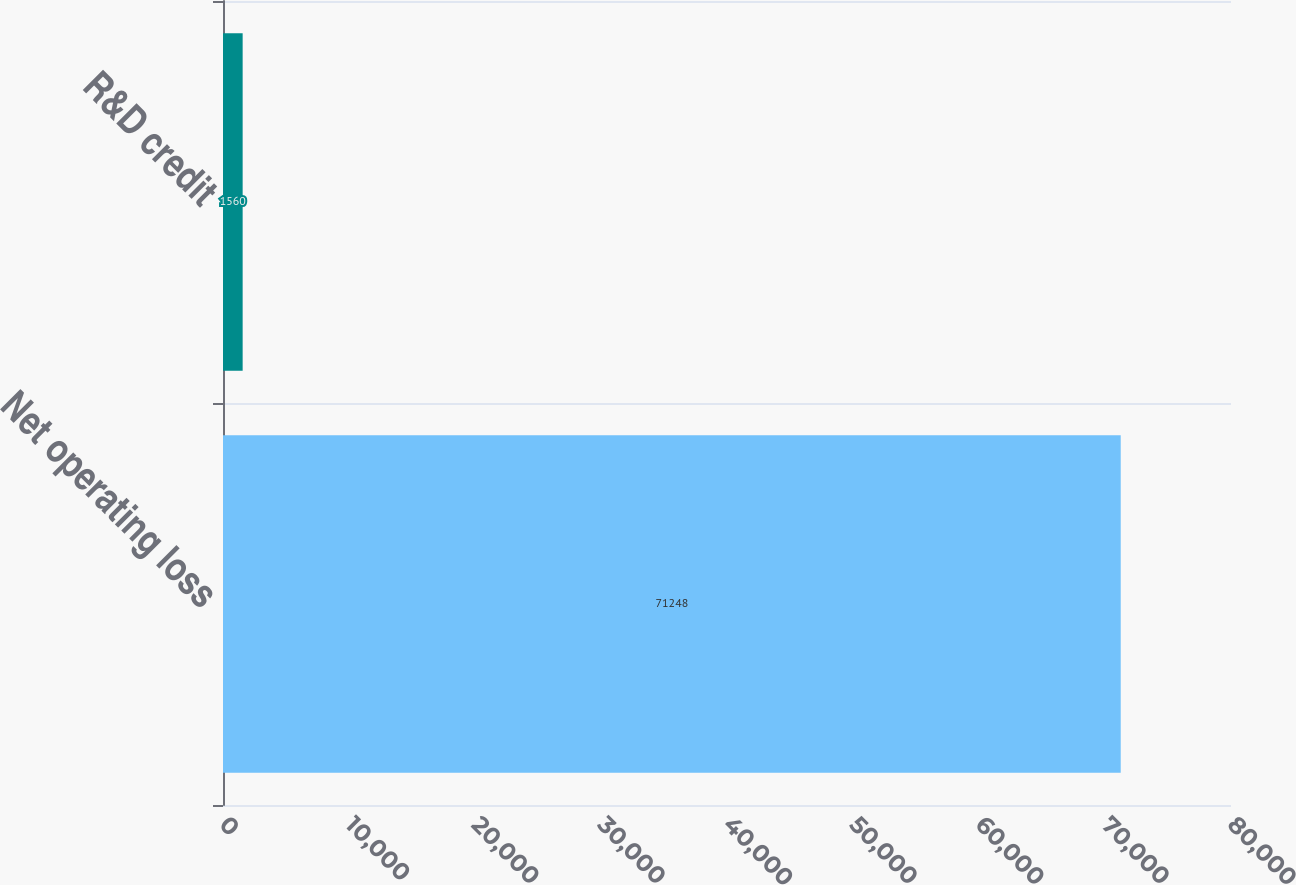<chart> <loc_0><loc_0><loc_500><loc_500><bar_chart><fcel>Net operating loss<fcel>R&D credit<nl><fcel>71248<fcel>1560<nl></chart> 